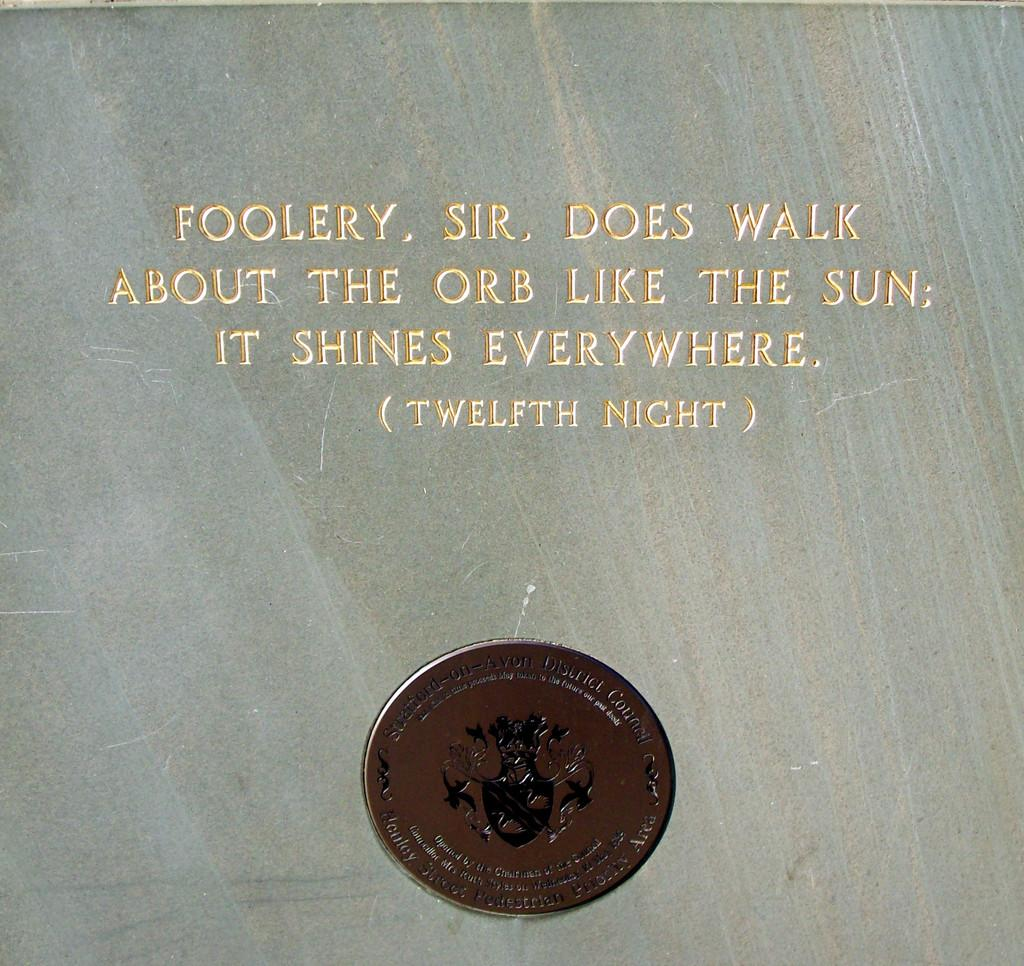Provide a one-sentence caption for the provided image. A front of a document that says Foolery. Sir. Does Walk About The Orb. Like The Sun It Shines Everywhere (Twelfth Night). 